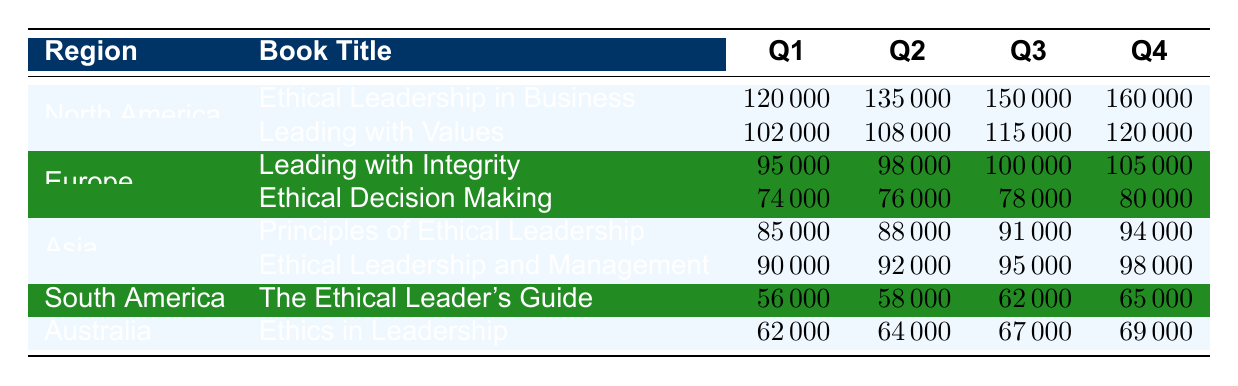What is the total sales for "Ethical Leadership in Business" in North America across all quarters? The total sales can be calculated by summing the sales figures for all quarters: 120000 + 135000 + 150000 + 160000 = 565000.
Answer: 565000 Which book had the highest sales in Q4 among all regions? In Q4, "Ethical Leadership in Business" had the highest sales of 160000 followed by "Leading with Values" at 120000 in North America. The maximum sales in Q4 is from "Ethical Leadership in Business".
Answer: Ethical Leadership in Business What is the average sales for "Leading with Integrity" in Europe across all quarters? The average sales can be calculated by summing the Q1, Q2, Q3, and Q4 values (95000 + 98000 + 100000 + 105000 = 397000) and dividing by the number of quarters (4): 397000 / 4 = 99250.
Answer: 99250 Does "The Ethical Leader's Guide" have Q1 sales above 60000? The Q1 sales for "The Ethical Leader's Guide" are 56000, which is below 60000.
Answer: No What is the combined sales for Asia's books in Q2? The total sales for Asia in Q2 can be calculated by adding the sales figures for both books: 88000 (Principles of Ethical Leadership) + 92000 (Ethical Leadership and Management) = 180000.
Answer: 180000 Which region has the book with the lowest sales in Q3? In Q3, "The Ethical Leader's Guide" from South America had the lowest sales of 62000. Comparing Q3 sales from all books and regions, we see that it is the lowest figure.
Answer: South America What is the difference in sales between Q4 and Q1 for "Ethics in Leadership" in Australia? The sales for "Ethics in Leadership" in Q4 is 69000 and in Q1 is 62000. The difference can be calculated as: 69000 - 62000 = 7000.
Answer: 7000 Is it true that the total sales of "Ethical Decision Making" in Europe increased every quarter? The sales figures for "Ethical Decision Making" are Q1: 74000, Q2: 76000, Q3: 78000, Q4: 80000. These numbers show an increase each quarter.
Answer: Yes What is the total sales of all books in North America for Q3? The total for North America in Q3 sums "Ethical Leadership in Business" (150000) and "Leading with Values" (115000), resulting in 150000 + 115000 = 265000.
Answer: 265000 